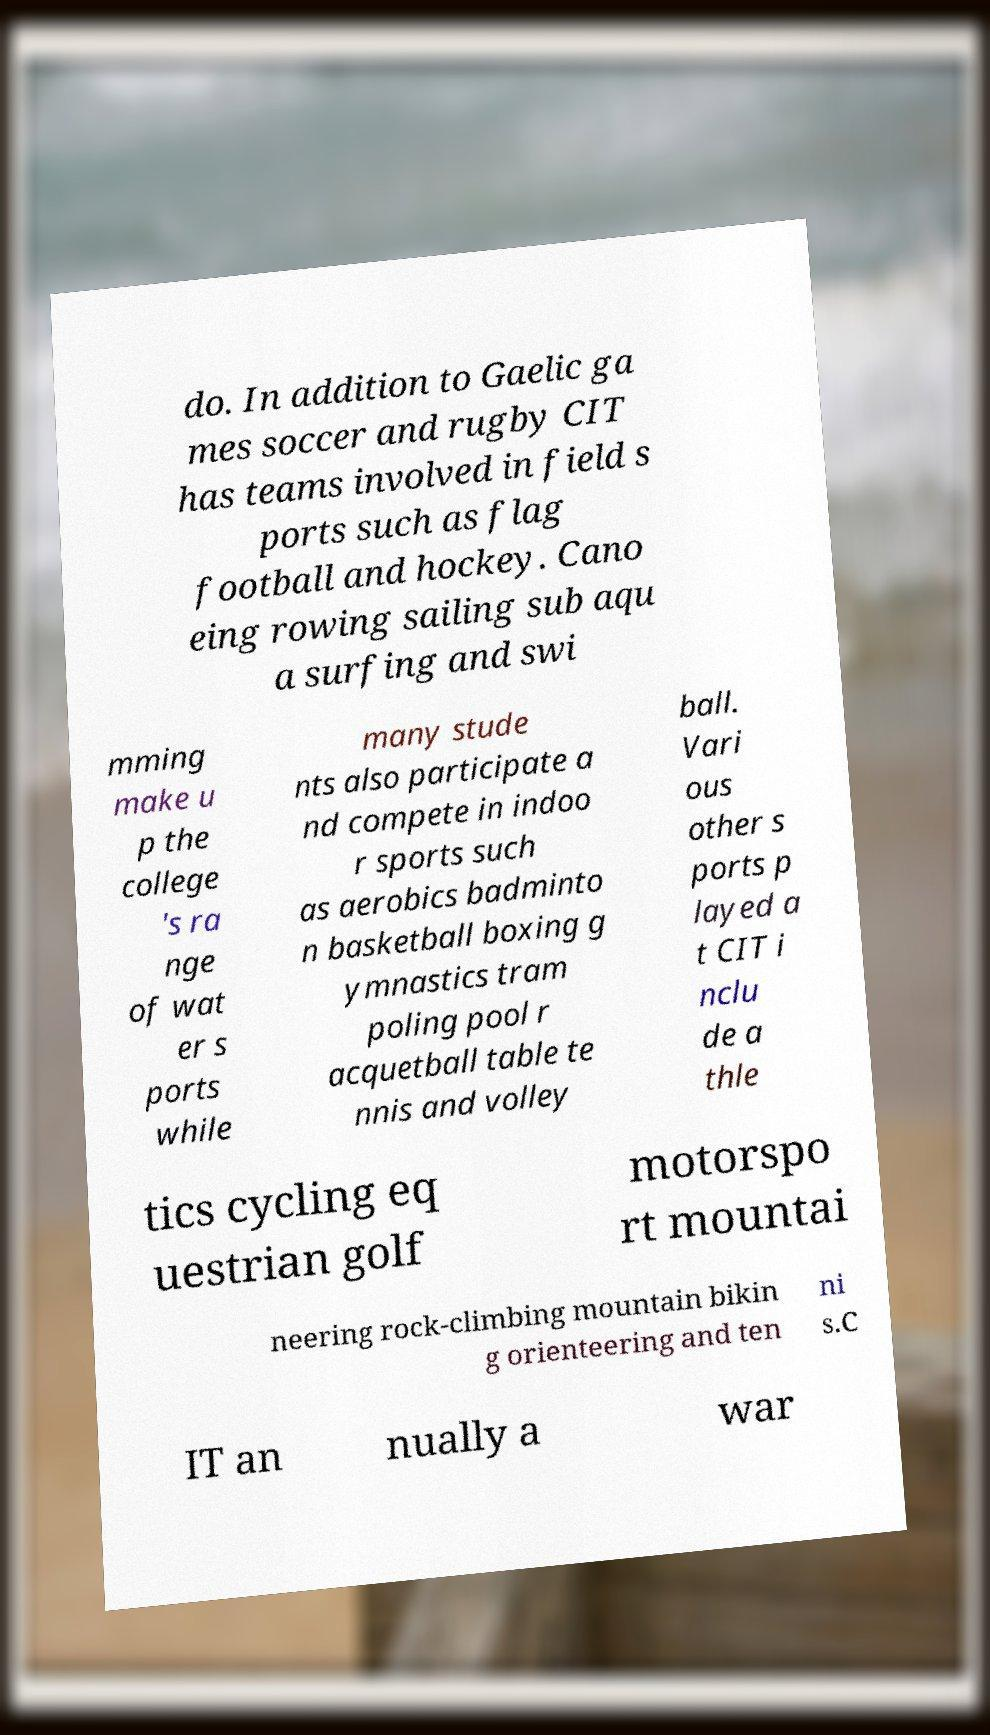Please identify and transcribe the text found in this image. do. In addition to Gaelic ga mes soccer and rugby CIT has teams involved in field s ports such as flag football and hockey. Cano eing rowing sailing sub aqu a surfing and swi mming make u p the college 's ra nge of wat er s ports while many stude nts also participate a nd compete in indoo r sports such as aerobics badminto n basketball boxing g ymnastics tram poling pool r acquetball table te nnis and volley ball. Vari ous other s ports p layed a t CIT i nclu de a thle tics cycling eq uestrian golf motorspo rt mountai neering rock-climbing mountain bikin g orienteering and ten ni s.C IT an nually a war 